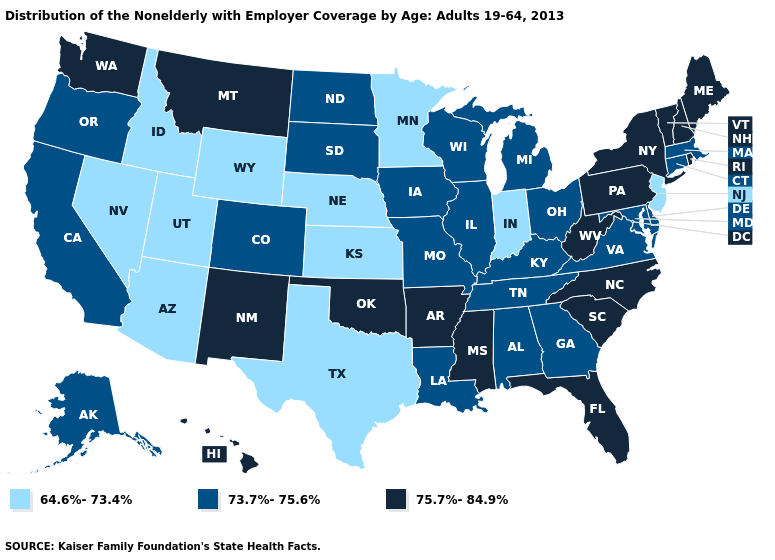What is the highest value in the USA?
Answer briefly. 75.7%-84.9%. What is the lowest value in the USA?
Quick response, please. 64.6%-73.4%. Does Ohio have a lower value than Michigan?
Short answer required. No. Does the map have missing data?
Be succinct. No. Does Alaska have a higher value than Wyoming?
Concise answer only. Yes. Among the states that border Wyoming , which have the lowest value?
Keep it brief. Idaho, Nebraska, Utah. What is the highest value in states that border Washington?
Give a very brief answer. 73.7%-75.6%. Name the states that have a value in the range 73.7%-75.6%?
Write a very short answer. Alabama, Alaska, California, Colorado, Connecticut, Delaware, Georgia, Illinois, Iowa, Kentucky, Louisiana, Maryland, Massachusetts, Michigan, Missouri, North Dakota, Ohio, Oregon, South Dakota, Tennessee, Virginia, Wisconsin. Does Illinois have the same value as Indiana?
Short answer required. No. What is the value of Kansas?
Quick response, please. 64.6%-73.4%. What is the highest value in the West ?
Give a very brief answer. 75.7%-84.9%. What is the lowest value in the South?
Answer briefly. 64.6%-73.4%. What is the lowest value in states that border New Hampshire?
Give a very brief answer. 73.7%-75.6%. What is the lowest value in states that border Kansas?
Keep it brief. 64.6%-73.4%. Does Kentucky have a lower value than Rhode Island?
Quick response, please. Yes. 